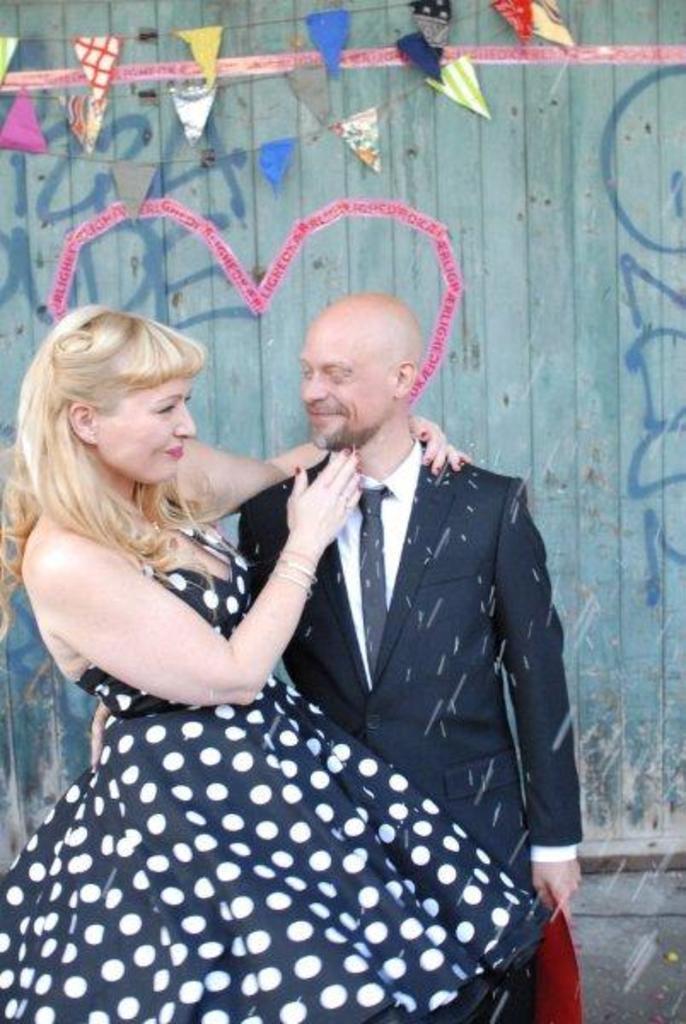Can you describe this image briefly? In this image we can see a man and a lady standing and smiling. In the background there is a wall and we can see decors placed on the wall. We can see graffiti on the wall. 